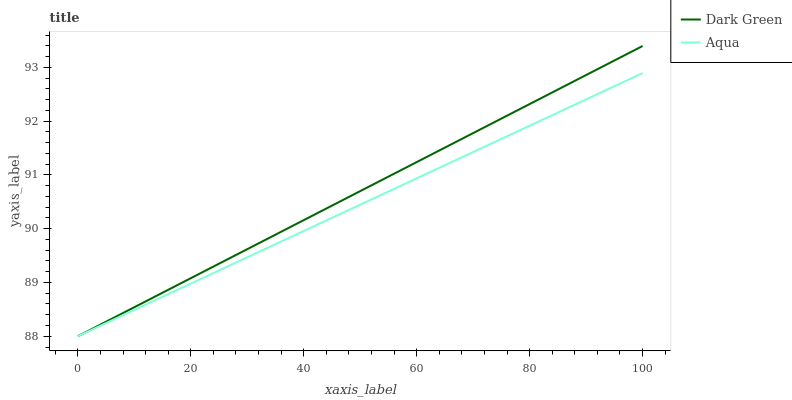Does Aqua have the minimum area under the curve?
Answer yes or no. Yes. Does Dark Green have the maximum area under the curve?
Answer yes or no. Yes. Does Dark Green have the minimum area under the curve?
Answer yes or no. No. Is Aqua the smoothest?
Answer yes or no. Yes. Is Dark Green the roughest?
Answer yes or no. Yes. Is Dark Green the smoothest?
Answer yes or no. No. Does Aqua have the lowest value?
Answer yes or no. Yes. Does Dark Green have the highest value?
Answer yes or no. Yes. Does Dark Green intersect Aqua?
Answer yes or no. Yes. Is Dark Green less than Aqua?
Answer yes or no. No. Is Dark Green greater than Aqua?
Answer yes or no. No. 